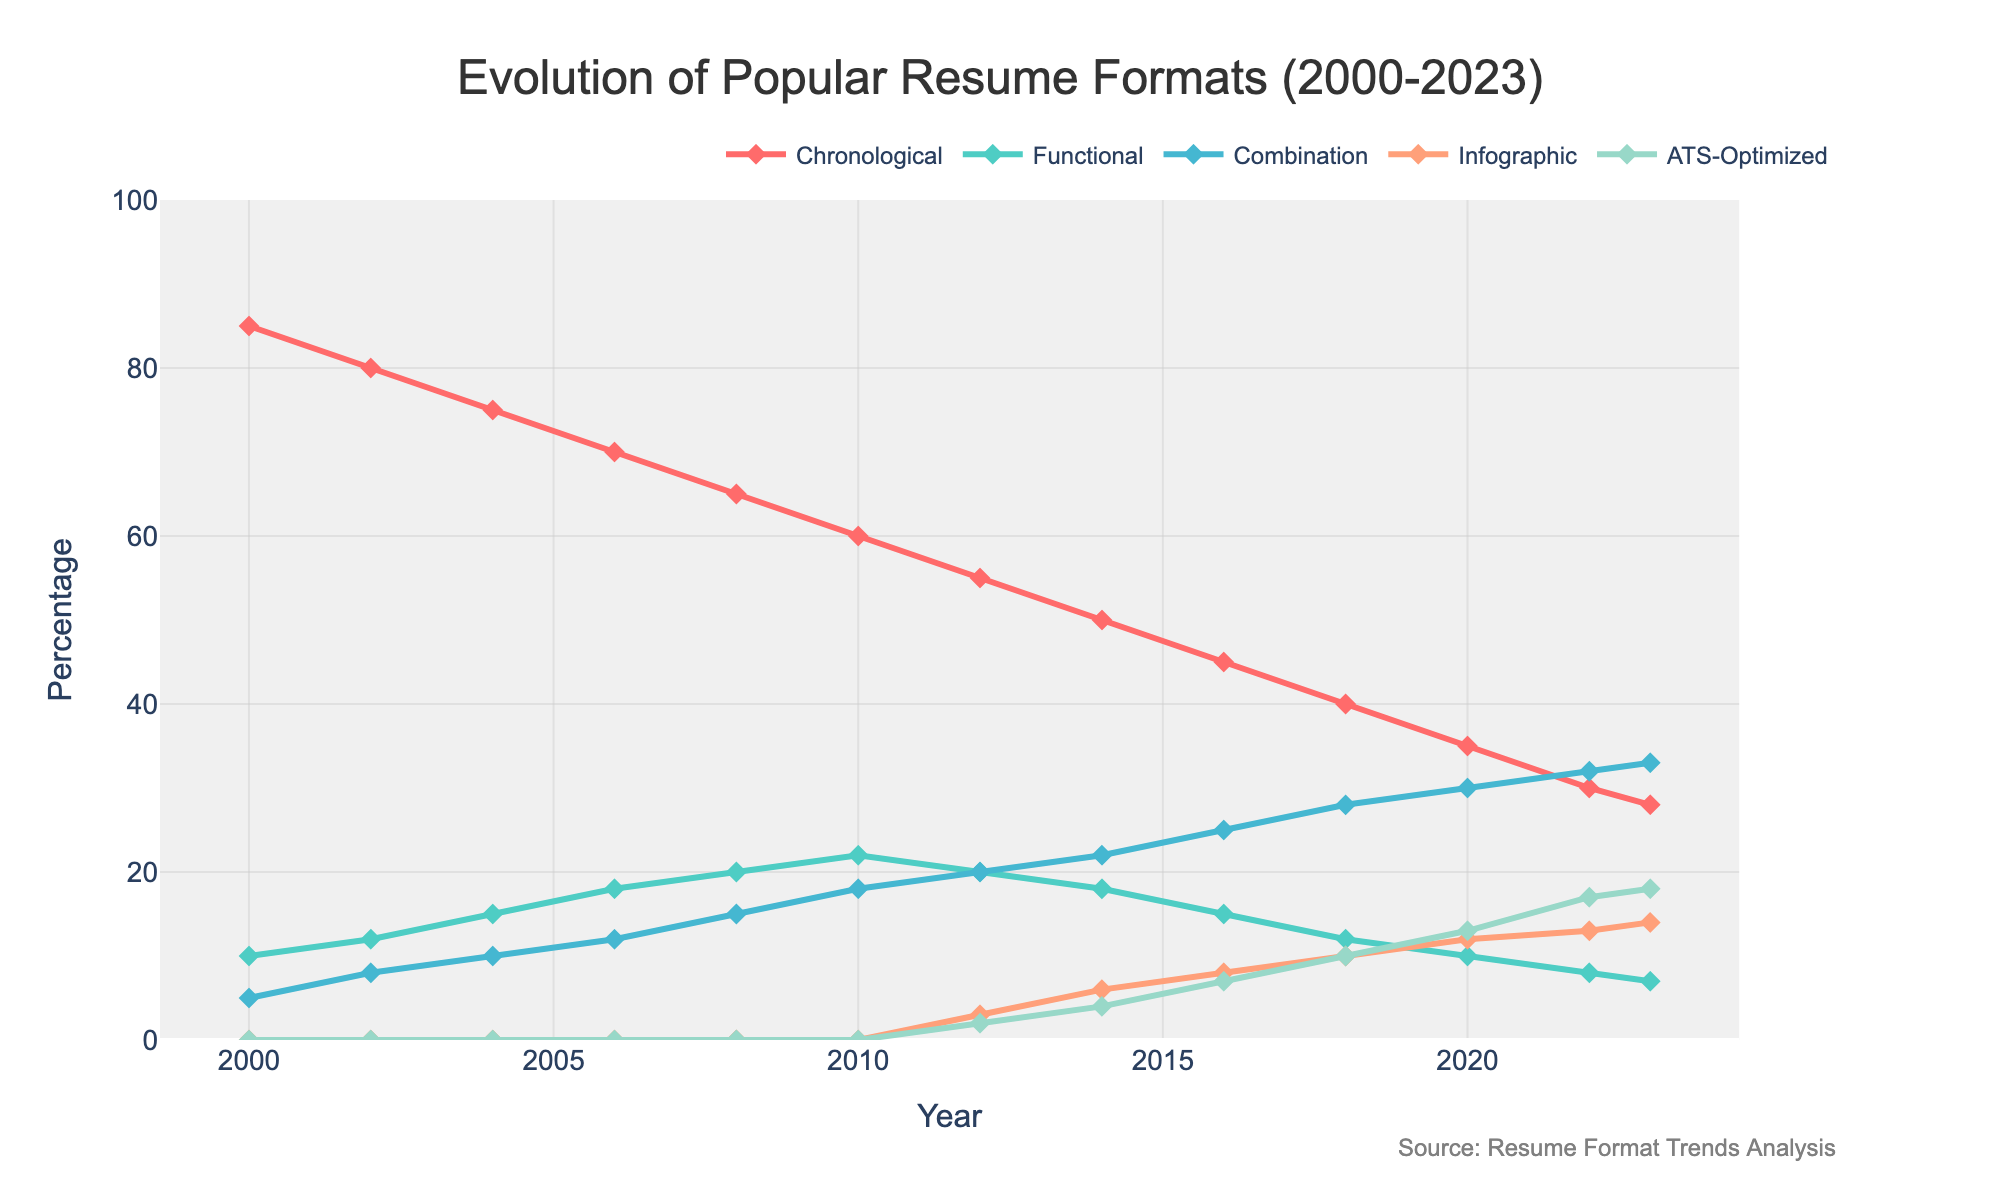What is the trend for Chronological resume formats from 2000 to 2023? The Chronological format shows a clear downward trend from 85% in 2000 to 28% in 2023. Each year, there is a steady decrease in its popularity.
Answer: Downward trend Which resume format shows the greatest increase in popularity from 2000 to 2023? Infographic and ATS-Optimized resumes show no popularity in 2000, but Infographic format rises to 14% and ATS-Optimized reaches 18% by 2023. ATS-Optimized shows the greatest increase since it didn't exist in 2000 and significantly increased popularity.
Answer: ATS-Optimized How do Combination and Functional resume formats compare in 2023? In 2023, the Combination format stands at 33%, while the Functional format is at 7%. Thus, the Combination format is more popular.
Answer: Combination: 33%, Functional: 7% What was the popularity of the Combination resume format in 2010, 2018, and 2023? In 2010, the Combination format was at 18%. In 2018, it increased to 28%. By 2023, it reached 33%. This shows a notable upward trend over the years.
Answer: 18%, 28%, 33% Which resume format had a constant introduction and growth trend starting from 2012? Infographic resumes appeared for the first time in 2012 at 3% and consistently grew to 14% in 2023.
Answer: Infographic Calculate the average popularity for Functional resumes from 2000 to 2010. Functional resumes had percentages of 10 in 2000, 12 in 2002, 15 in 2004, 18 in 2006, 20 in 2008, and 22 in 2010. Adding these gives 97, and the average is 97/6, approximately 16.17%.
Answer: 16.17% Which resume format experienced a decline and then stabilization in its popularity? The Functional resume format increased until 2010, then declined and stabilized around 7-8% from 2014 to 2023.
Answer: Functional How much did the popularity of ATS-Optimized resumes increase from 2020 to 2023? In 2020, ATS-Optimized resumes were at 13%. By 2023, they increased to 18%. The increase is 18 - 13 = 5%.
Answer: 5% Compare the popularity trends of Infographic and Combination resumes between 2012 and 2023. Both formats show an increasing trend from 2012 to 2023. Infographic resumes increased from 3% to 14%, while Combination resumes increased from 20% to 33%.
Answer: Both increased, Infographic: 3% to 14%, Combination: 20% to 33% What is the total combined popularity percentage for Chronological and Combination formats in 2023? In 2023, the Chronological format is at 28%, and the Combination format is at 33%. Summing these gives 28 + 33 = 61%.
Answer: 61% 